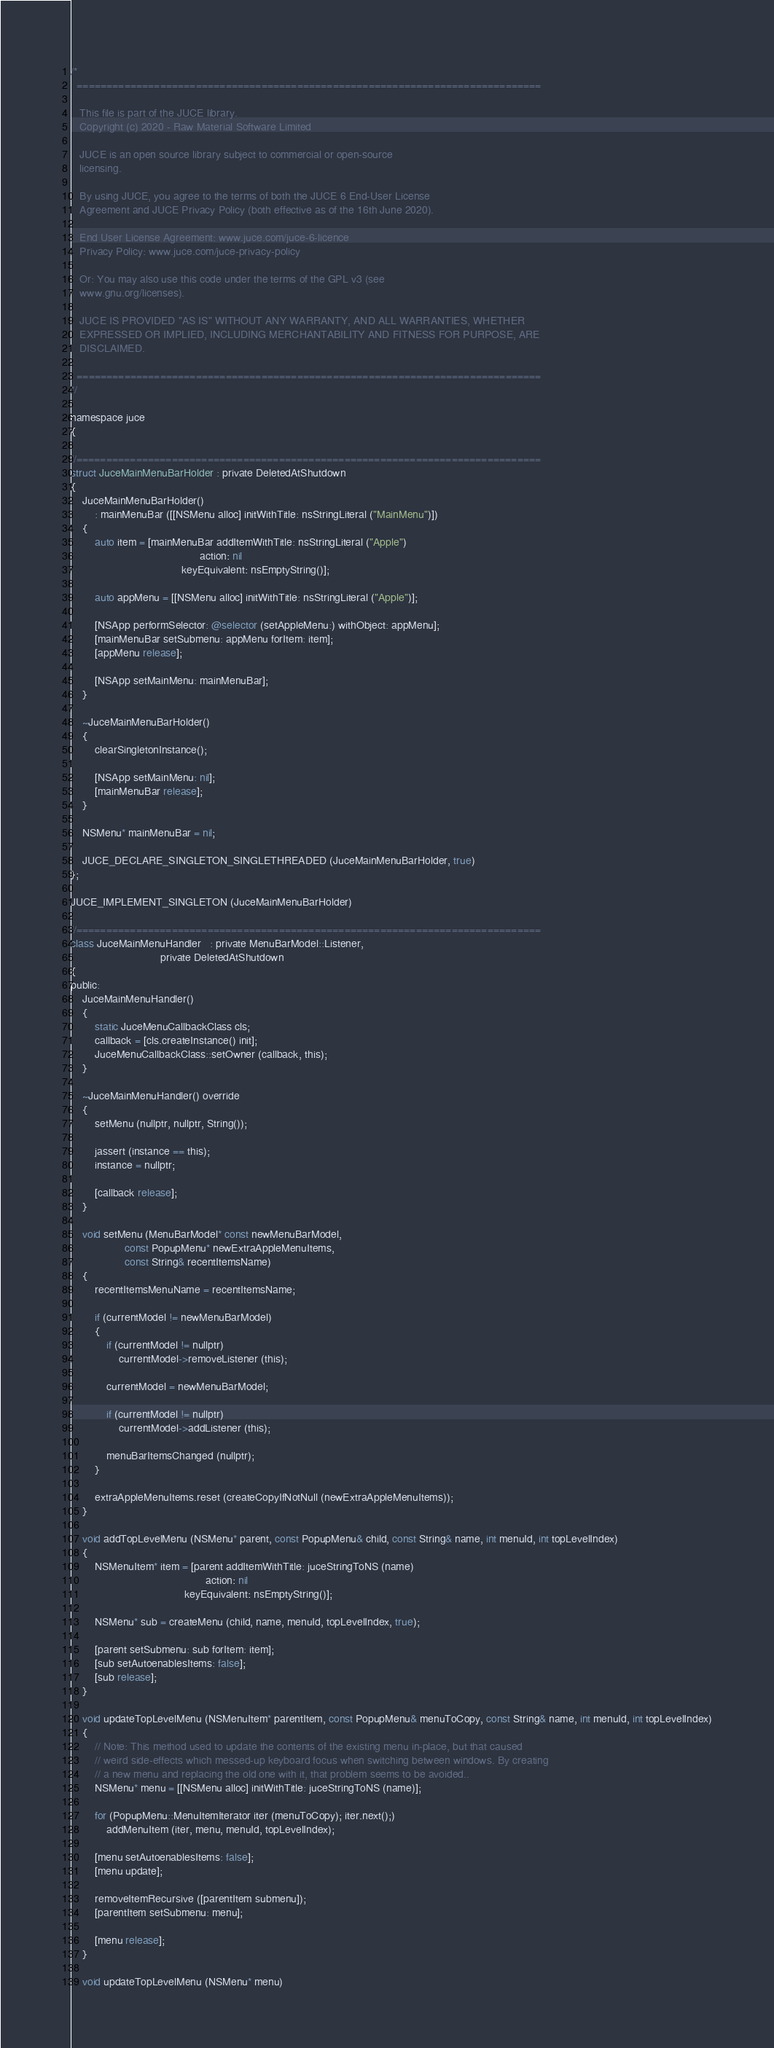Convert code to text. <code><loc_0><loc_0><loc_500><loc_500><_ObjectiveC_>/*
  ==============================================================================

   This file is part of the JUCE library.
   Copyright (c) 2020 - Raw Material Software Limited

   JUCE is an open source library subject to commercial or open-source
   licensing.

   By using JUCE, you agree to the terms of both the JUCE 6 End-User License
   Agreement and JUCE Privacy Policy (both effective as of the 16th June 2020).

   End User License Agreement: www.juce.com/juce-6-licence
   Privacy Policy: www.juce.com/juce-privacy-policy

   Or: You may also use this code under the terms of the GPL v3 (see
   www.gnu.org/licenses).

   JUCE IS PROVIDED "AS IS" WITHOUT ANY WARRANTY, AND ALL WARRANTIES, WHETHER
   EXPRESSED OR IMPLIED, INCLUDING MERCHANTABILITY AND FITNESS FOR PURPOSE, ARE
   DISCLAIMED.

  ==============================================================================
*/

namespace juce
{

//==============================================================================
struct JuceMainMenuBarHolder : private DeletedAtShutdown
{
    JuceMainMenuBarHolder()
        : mainMenuBar ([[NSMenu alloc] initWithTitle: nsStringLiteral ("MainMenu")])
    {
        auto item = [mainMenuBar addItemWithTitle: nsStringLiteral ("Apple")
                                           action: nil
                                     keyEquivalent: nsEmptyString()];

        auto appMenu = [[NSMenu alloc] initWithTitle: nsStringLiteral ("Apple")];

        [NSApp performSelector: @selector (setAppleMenu:) withObject: appMenu];
        [mainMenuBar setSubmenu: appMenu forItem: item];
        [appMenu release];

        [NSApp setMainMenu: mainMenuBar];
    }

    ~JuceMainMenuBarHolder()
    {
        clearSingletonInstance();

        [NSApp setMainMenu: nil];
        [mainMenuBar release];
    }

    NSMenu* mainMenuBar = nil;

    JUCE_DECLARE_SINGLETON_SINGLETHREADED (JuceMainMenuBarHolder, true)
};

JUCE_IMPLEMENT_SINGLETON (JuceMainMenuBarHolder)

//==============================================================================
class JuceMainMenuHandler   : private MenuBarModel::Listener,
                              private DeletedAtShutdown
{
public:
    JuceMainMenuHandler()
    {
        static JuceMenuCallbackClass cls;
        callback = [cls.createInstance() init];
        JuceMenuCallbackClass::setOwner (callback, this);
    }

    ~JuceMainMenuHandler() override
    {
        setMenu (nullptr, nullptr, String());

        jassert (instance == this);
        instance = nullptr;

        [callback release];
    }

    void setMenu (MenuBarModel* const newMenuBarModel,
                  const PopupMenu* newExtraAppleMenuItems,
                  const String& recentItemsName)
    {
        recentItemsMenuName = recentItemsName;

        if (currentModel != newMenuBarModel)
        {
            if (currentModel != nullptr)
                currentModel->removeListener (this);

            currentModel = newMenuBarModel;

            if (currentModel != nullptr)
                currentModel->addListener (this);

            menuBarItemsChanged (nullptr);
        }

        extraAppleMenuItems.reset (createCopyIfNotNull (newExtraAppleMenuItems));
    }

    void addTopLevelMenu (NSMenu* parent, const PopupMenu& child, const String& name, int menuId, int topLevelIndex)
    {
        NSMenuItem* item = [parent addItemWithTitle: juceStringToNS (name)
                                             action: nil
                                      keyEquivalent: nsEmptyString()];

        NSMenu* sub = createMenu (child, name, menuId, topLevelIndex, true);

        [parent setSubmenu: sub forItem: item];
        [sub setAutoenablesItems: false];
        [sub release];
    }

    void updateTopLevelMenu (NSMenuItem* parentItem, const PopupMenu& menuToCopy, const String& name, int menuId, int topLevelIndex)
    {
        // Note: This method used to update the contents of the existing menu in-place, but that caused
        // weird side-effects which messed-up keyboard focus when switching between windows. By creating
        // a new menu and replacing the old one with it, that problem seems to be avoided..
        NSMenu* menu = [[NSMenu alloc] initWithTitle: juceStringToNS (name)];

        for (PopupMenu::MenuItemIterator iter (menuToCopy); iter.next();)
            addMenuItem (iter, menu, menuId, topLevelIndex);

        [menu setAutoenablesItems: false];
        [menu update];

        removeItemRecursive ([parentItem submenu]);
        [parentItem setSubmenu: menu];

        [menu release];
    }

    void updateTopLevelMenu (NSMenu* menu)</code> 